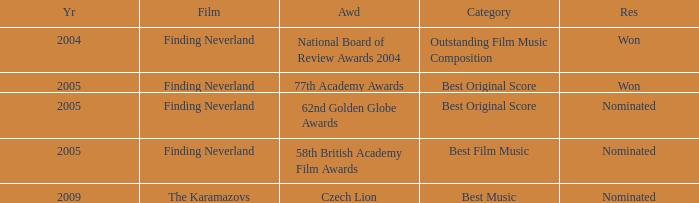For how many years did the 62nd golden globe awards take place? 2005.0. Parse the full table. {'header': ['Yr', 'Film', 'Awd', 'Category', 'Res'], 'rows': [['2004', 'Finding Neverland', 'National Board of Review Awards 2004', 'Outstanding Film Music Composition', 'Won'], ['2005', 'Finding Neverland', '77th Academy Awards', 'Best Original Score', 'Won'], ['2005', 'Finding Neverland', '62nd Golden Globe Awards', 'Best Original Score', 'Nominated'], ['2005', 'Finding Neverland', '58th British Academy Film Awards', 'Best Film Music', 'Nominated'], ['2009', 'The Karamazovs', 'Czech Lion', 'Best Music', 'Nominated']]} 